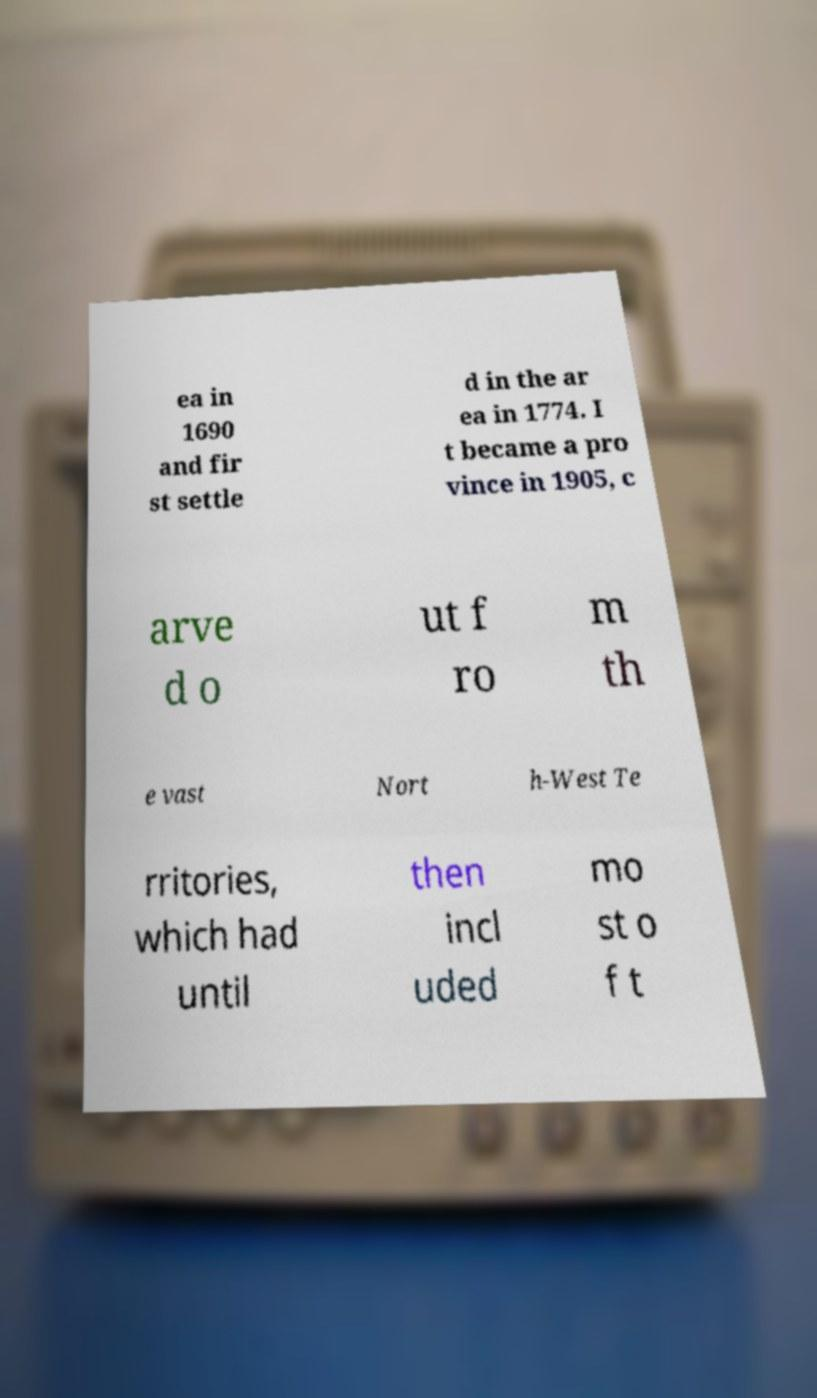For documentation purposes, I need the text within this image transcribed. Could you provide that? ea in 1690 and fir st settle d in the ar ea in 1774. I t became a pro vince in 1905, c arve d o ut f ro m th e vast Nort h-West Te rritories, which had until then incl uded mo st o f t 